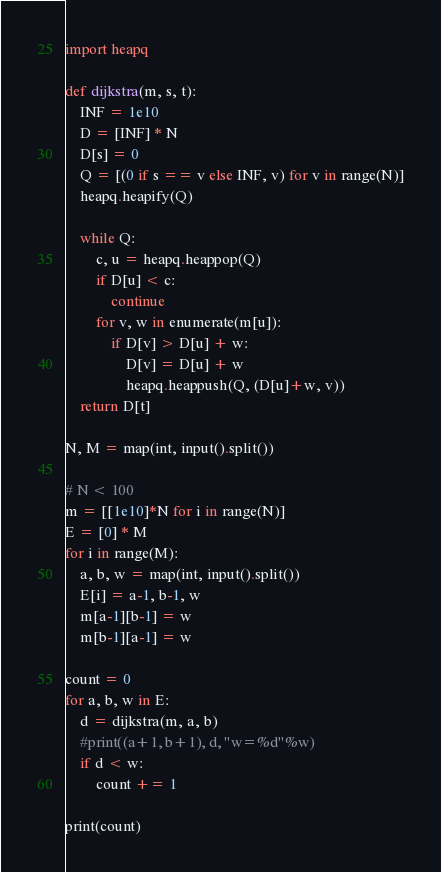Convert code to text. <code><loc_0><loc_0><loc_500><loc_500><_Python_>import heapq

def dijkstra(m, s, t):
    INF = 1e10
    D = [INF] * N
    D[s] = 0
    Q = [(0 if s == v else INF, v) for v in range(N)]
    heapq.heapify(Q)

    while Q:
        c, u = heapq.heappop(Q)
        if D[u] < c:
            continue
        for v, w in enumerate(m[u]):
            if D[v] > D[u] + w:
                D[v] = D[u] + w
                heapq.heappush(Q, (D[u]+w, v))
    return D[t] 

N, M = map(int, input().split())

# N < 100
m = [[1e10]*N for i in range(N)]
E = [0] * M
for i in range(M):
    a, b, w = map(int, input().split())
    E[i] = a-1, b-1, w
    m[a-1][b-1] = w
    m[b-1][a-1] = w

count = 0
for a, b, w in E:
    d = dijkstra(m, a, b)
    #print((a+1, b+1), d, "w=%d"%w)
    if d < w:
        count += 1

print(count)
</code> 